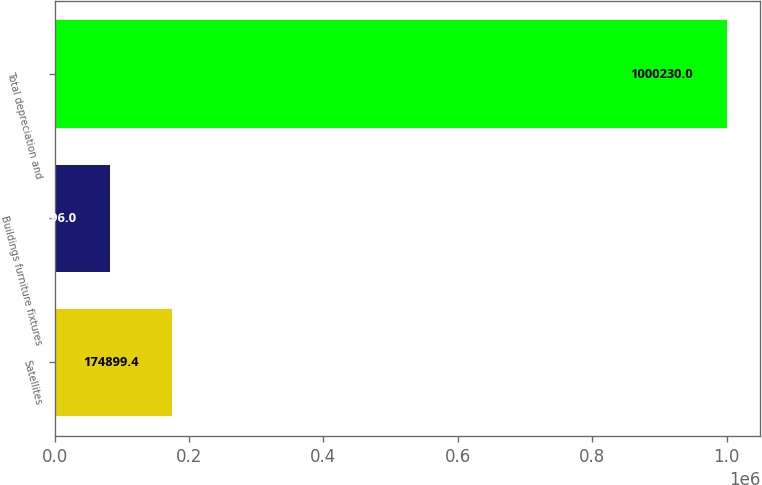<chart> <loc_0><loc_0><loc_500><loc_500><bar_chart><fcel>Satellites<fcel>Buildings furniture fixtures<fcel>Total depreciation and<nl><fcel>174899<fcel>83196<fcel>1.00023e+06<nl></chart> 